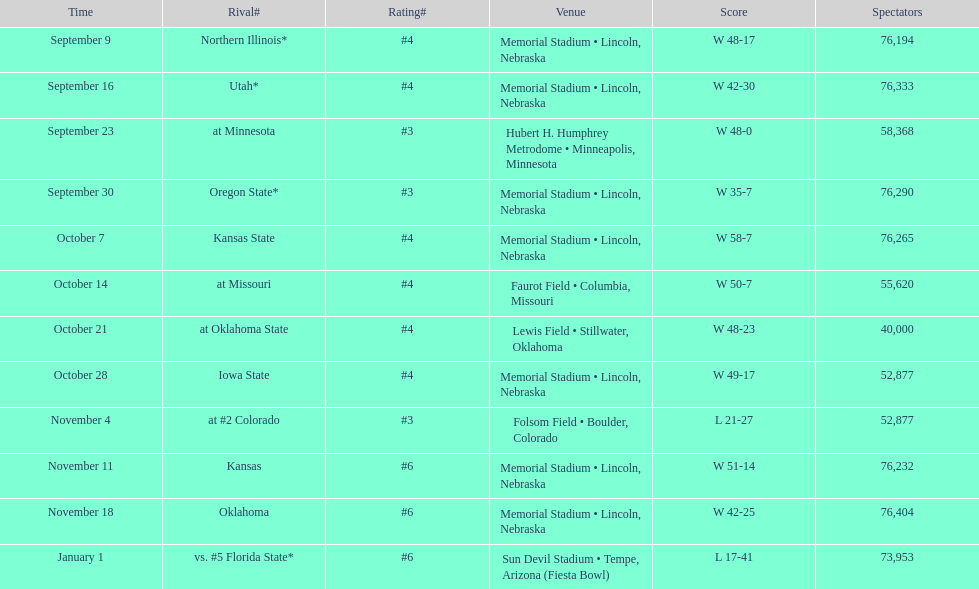I'm looking to parse the entire table for insights. Could you assist me with that? {'header': ['Time', 'Rival#', 'Rating#', 'Venue', 'Score', 'Spectators'], 'rows': [['September 9', 'Northern Illinois*', '#4', 'Memorial Stadium • Lincoln, Nebraska', 'W\xa048-17', '76,194'], ['September 16', 'Utah*', '#4', 'Memorial Stadium • Lincoln, Nebraska', 'W\xa042-30', '76,333'], ['September 23', 'at\xa0Minnesota', '#3', 'Hubert H. Humphrey Metrodome • Minneapolis, Minnesota', 'W\xa048-0', '58,368'], ['September 30', 'Oregon State*', '#3', 'Memorial Stadium • Lincoln, Nebraska', 'W\xa035-7', '76,290'], ['October 7', 'Kansas State', '#4', 'Memorial Stadium • Lincoln, Nebraska', 'W\xa058-7', '76,265'], ['October 14', 'at\xa0Missouri', '#4', 'Faurot Field • Columbia, Missouri', 'W\xa050-7', '55,620'], ['October 21', 'at\xa0Oklahoma State', '#4', 'Lewis Field • Stillwater, Oklahoma', 'W\xa048-23', '40,000'], ['October 28', 'Iowa State', '#4', 'Memorial Stadium • Lincoln, Nebraska', 'W\xa049-17', '52,877'], ['November 4', 'at\xa0#2\xa0Colorado', '#3', 'Folsom Field • Boulder, Colorado', 'L\xa021-27', '52,877'], ['November 11', 'Kansas', '#6', 'Memorial Stadium • Lincoln, Nebraska', 'W\xa051-14', '76,232'], ['November 18', 'Oklahoma', '#6', 'Memorial Stadium • Lincoln, Nebraska', 'W\xa042-25', '76,404'], ['January 1', 'vs.\xa0#5\xa0Florida State*', '#6', 'Sun Devil Stadium • Tempe, Arizona (Fiesta Bowl)', 'L\xa017-41', '73,953']]} How many games did they win by more than 7? 10. 